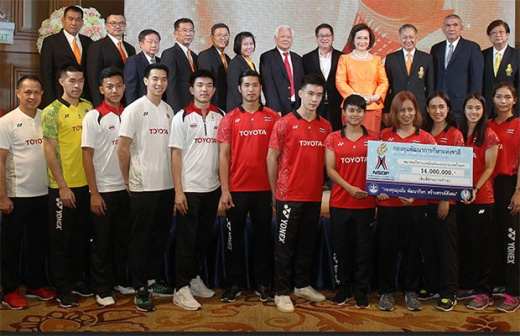How would you describe the expressions of the athletes? The athletes' expressions in the image exude a mix of excitement, pride, and gratitude. Their smiles are broad, reflecting their sense of achievement and joy at being recognized. There's a palpable energy in their body language, suggesting eagerness and readiness for future challenges. The moment captured radiates a sense of collective happiness and anticipation for the opportunities that the sponsorship might bring. What is the significance of the backdrop in the image? The backdrop, featuring a curtain and a chandelier, adds to the image's sense of formality and grandeur. It signifies that the event is being held in a prestigious location, likely a hall known for hosting significant events. The backdrop enhances the celebratory atmosphere and underscores the importance of the occasion, providing a visual contrast between the athletes' spirited presence and the solemnity of the ceremony. This juxtaposition highlights the merging of youthful athletic energy with the institutional support of established organizations. 